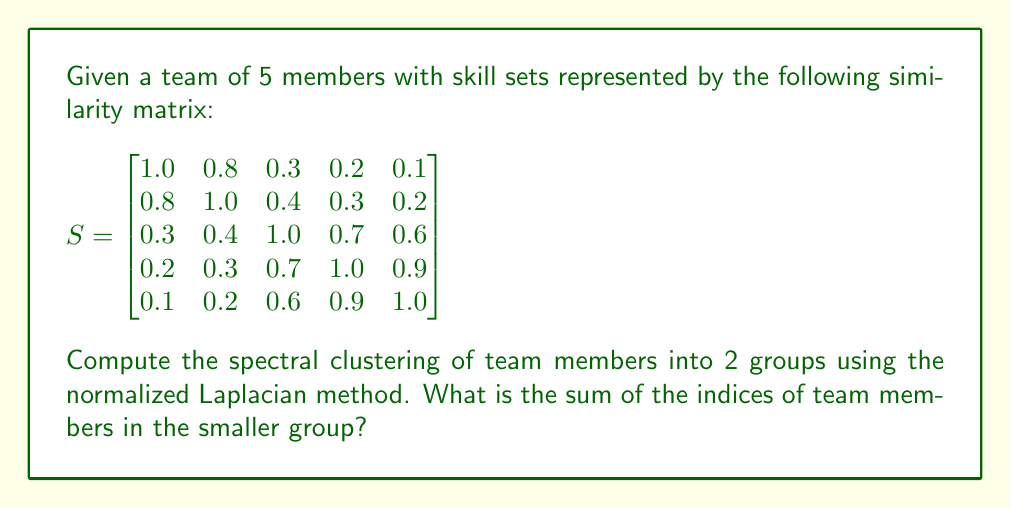Show me your answer to this math problem. 1. Compute the degree matrix $D$:
   $$D = \begin{bmatrix}
   2.4 & 0 & 0 & 0 & 0 \\
   0 & 2.7 & 0 & 0 & 0 \\
   0 & 0 & 3.0 & 0 & 0 \\
   0 & 0 & 0 & 3.1 & 0 \\
   0 & 0 & 0 & 0 & 2.8
   \end{bmatrix}$$

2. Compute the normalized Laplacian $L_{sym} = I - D^{-1/2}SD^{-1/2}$:
   $$L_{sym} = I - \begin{bmatrix}
   0.645 & 0.299 & 0.106 & 0.070 & 0.037 \\
   0.299 & 0.608 & 0.142 & 0.105 & 0.073 \\
   0.106 & 0.142 & 0.577 & 0.398 & 0.357 \\
   0.070 & 0.105 & 0.398 & 0.568 & 0.535 \\
   0.037 & 0.073 & 0.357 & 0.535 & 0.595
   \end{bmatrix}$$

3. Compute the eigenvectors of $L_{sym}$ and select the eigenvector $v_2$ corresponding to the second smallest eigenvalue.

4. Normalize $v_2$ to get $y$:
   $$y \approx [0.707, 0.707, -0.006, -0.013, -0.015]^T$$

5. Cluster the points based on the sign of the corresponding value in $y$:
   - Group 1 (positive): Members 1 and 2
   - Group 2 (negative): Members 3, 4, and 5

6. The smaller group is Group 1, containing members 1 and 2.

7. Sum of indices: 1 + 2 = 3
Answer: 3 